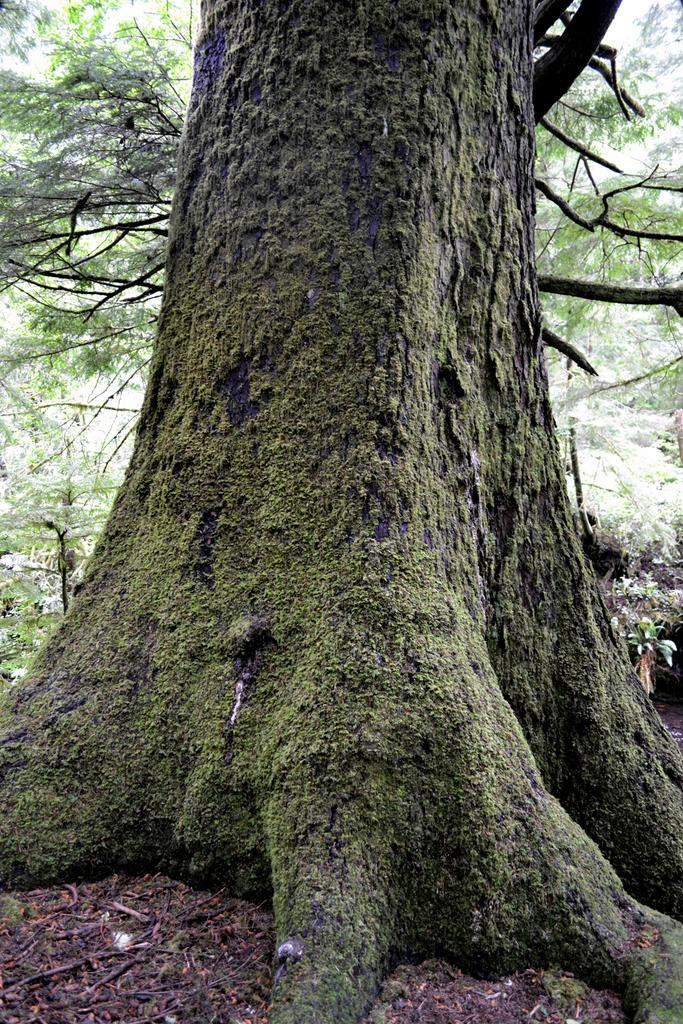What is the main subject of the image? The main subject of the image is a tree trunk. What else can be seen on the ground in the image? There are sticks on the ground in the image. What can be seen in the distance in the image? There are trees visible in the background of the image. What type of powder is being used to create the invention in the image? There is no invention or powder present in the image; it features a tree trunk, sticks on the ground, and trees in the background. 